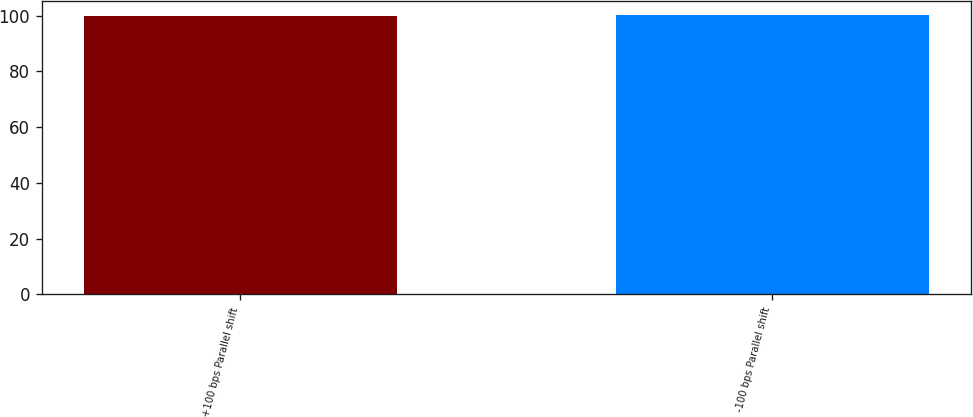<chart> <loc_0><loc_0><loc_500><loc_500><bar_chart><fcel>+100 bps Parallel shift<fcel>-100 bps Parallel shift<nl><fcel>100<fcel>100.1<nl></chart> 